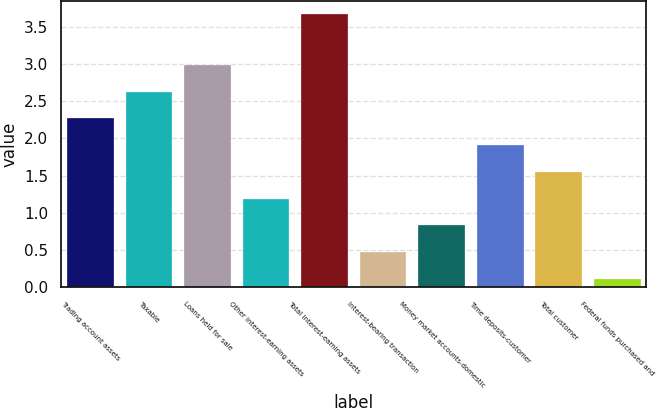<chart> <loc_0><loc_0><loc_500><loc_500><bar_chart><fcel>Trading account assets<fcel>Taxable<fcel>Loans held for sale<fcel>Other interest-earning assets<fcel>Total interest-earning assets<fcel>Interest-bearing transaction<fcel>Money market accounts-domestic<fcel>Time deposits-customer<fcel>Total customer<fcel>Federal funds purchased and<nl><fcel>2.27<fcel>2.63<fcel>2.99<fcel>1.19<fcel>3.67<fcel>0.47<fcel>0.83<fcel>1.91<fcel>1.55<fcel>0.11<nl></chart> 